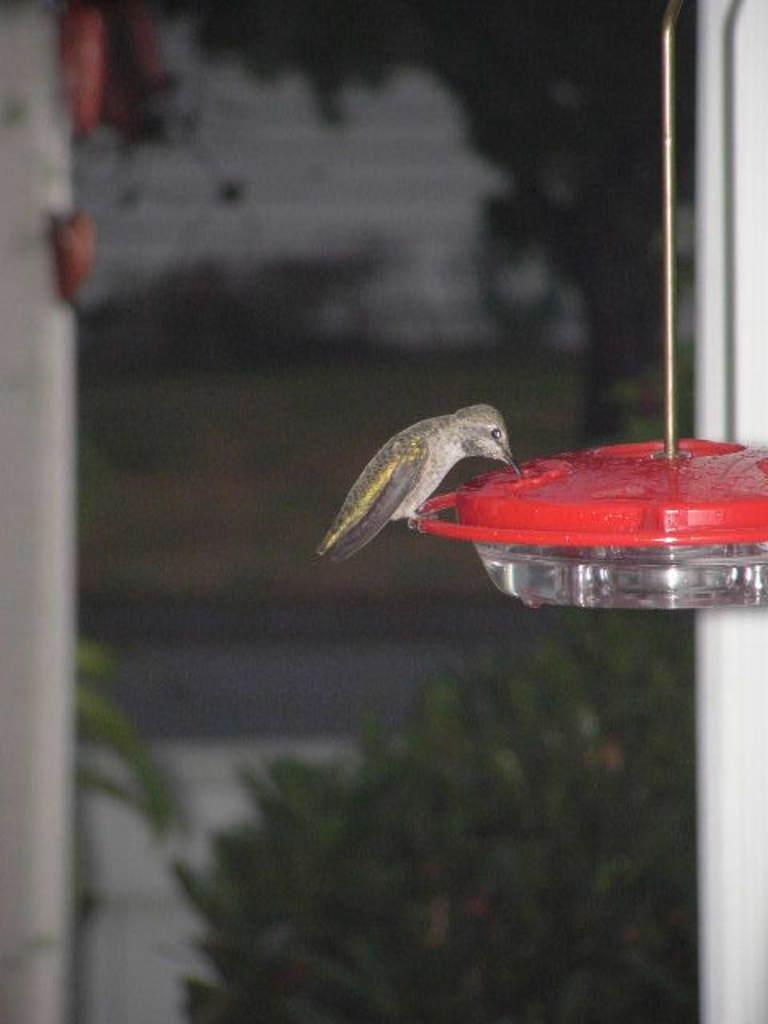Could you give a brief overview of what you see in this image? In this picture we can observe a bird which is in grey color. This bird is on the bowl which is hanging. The bird is drinking some water. We can observe a red color cap on the bowl. In the background we can observe some plants. 